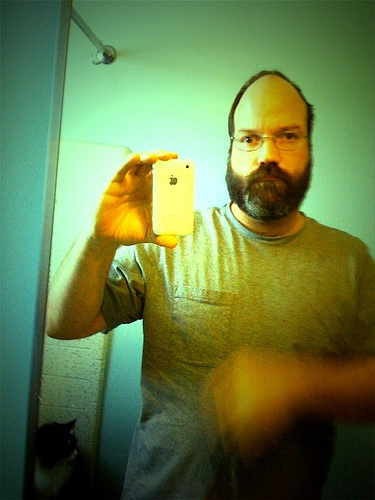Describe the objects in this image and their specific colors. I can see people in darkgreen, black, olive, and maroon tones, cat in black and darkgreen tones, and cell phone in darkgreen, khaki, yellow, lightyellow, and olive tones in this image. 